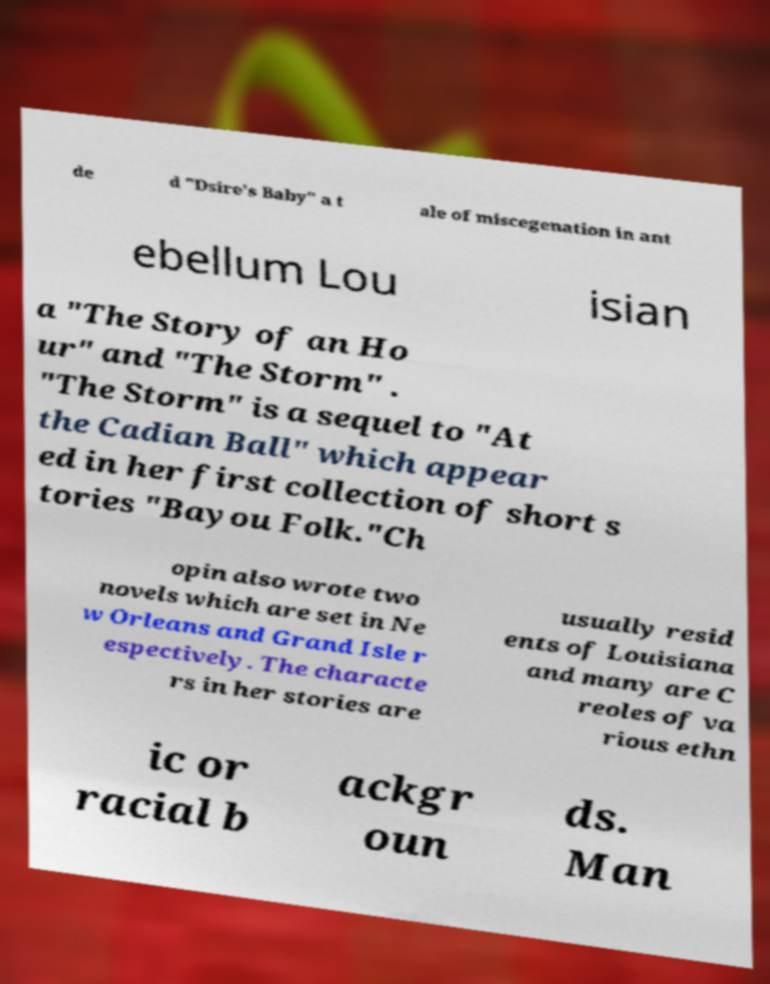Could you extract and type out the text from this image? de d "Dsire's Baby" a t ale of miscegenation in ant ebellum Lou isian a "The Story of an Ho ur" and "The Storm" . "The Storm" is a sequel to "At the Cadian Ball" which appear ed in her first collection of short s tories "Bayou Folk."Ch opin also wrote two novels which are set in Ne w Orleans and Grand Isle r espectively. The characte rs in her stories are usually resid ents of Louisiana and many are C reoles of va rious ethn ic or racial b ackgr oun ds. Man 